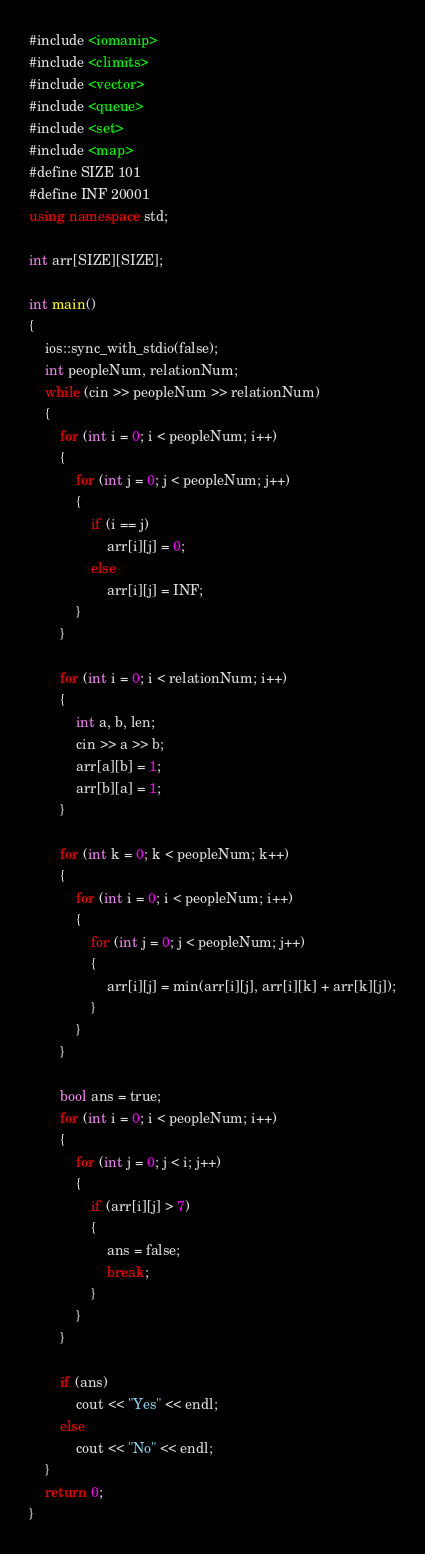<code> <loc_0><loc_0><loc_500><loc_500><_C++_>#include <iomanip>
#include <climits>
#include <vector>
#include <queue>
#include <set>
#include <map>
#define SIZE 101
#define INF 20001
using namespace std;

int arr[SIZE][SIZE];

int main()
{
    ios::sync_with_stdio(false);
    int peopleNum, relationNum;
    while (cin >> peopleNum >> relationNum)
    {
        for (int i = 0; i < peopleNum; i++)
        {
            for (int j = 0; j < peopleNum; j++)
            {
                if (i == j)
                    arr[i][j] = 0;
                else
                    arr[i][j] = INF;
            }
        }

        for (int i = 0; i < relationNum; i++)
        {
            int a, b, len;
            cin >> a >> b;
            arr[a][b] = 1;
            arr[b][a] = 1;
        }

        for (int k = 0; k < peopleNum; k++)
        {
            for (int i = 0; i < peopleNum; i++)
            {
                for (int j = 0; j < peopleNum; j++)
                {
                    arr[i][j] = min(arr[i][j], arr[i][k] + arr[k][j]);
                }
            }
        }

        bool ans = true;
        for (int i = 0; i < peopleNum; i++)
        {
            for (int j = 0; j < i; j++)
            {
                if (arr[i][j] > 7)
                {
                    ans = false;
                    break;
                }
            }
        }

        if (ans)
            cout << "Yes" << endl;
        else
            cout << "No" << endl;
    }
    return 0;
}
</code> 